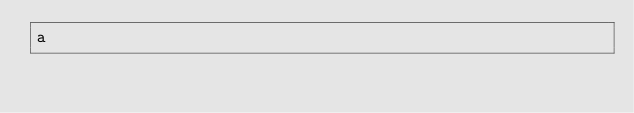<code> <loc_0><loc_0><loc_500><loc_500><_Java_>a</code> 